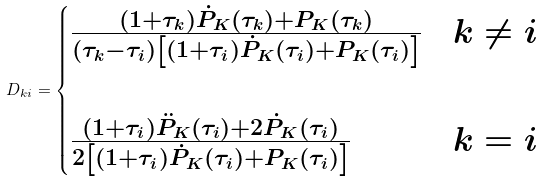<formula> <loc_0><loc_0><loc_500><loc_500>D _ { k i } = \begin{cases} \frac { ( 1 + \tau _ { k } ) \dot { P } _ { K } ( \tau _ { k } ) + P _ { K } ( \tau _ { k } ) } { ( \tau _ { k } - \tau _ { i } ) \left [ ( 1 + \tau _ { i } ) \dot { P } _ { K } ( \tau _ { i } ) + P _ { K } ( \tau _ { i } ) \right ] } & k \neq i \\ \\ \frac { ( 1 + \tau _ { i } ) \ddot { P } _ { K } ( \tau _ { i } ) + 2 \dot { P } _ { K } ( \tau _ { i } ) } { 2 \left [ ( 1 + \tau _ { i } ) \dot { P } _ { K } ( \tau _ { i } ) + P _ { K } ( \tau _ { i } ) \right ] } & k = i \end{cases}</formula> 